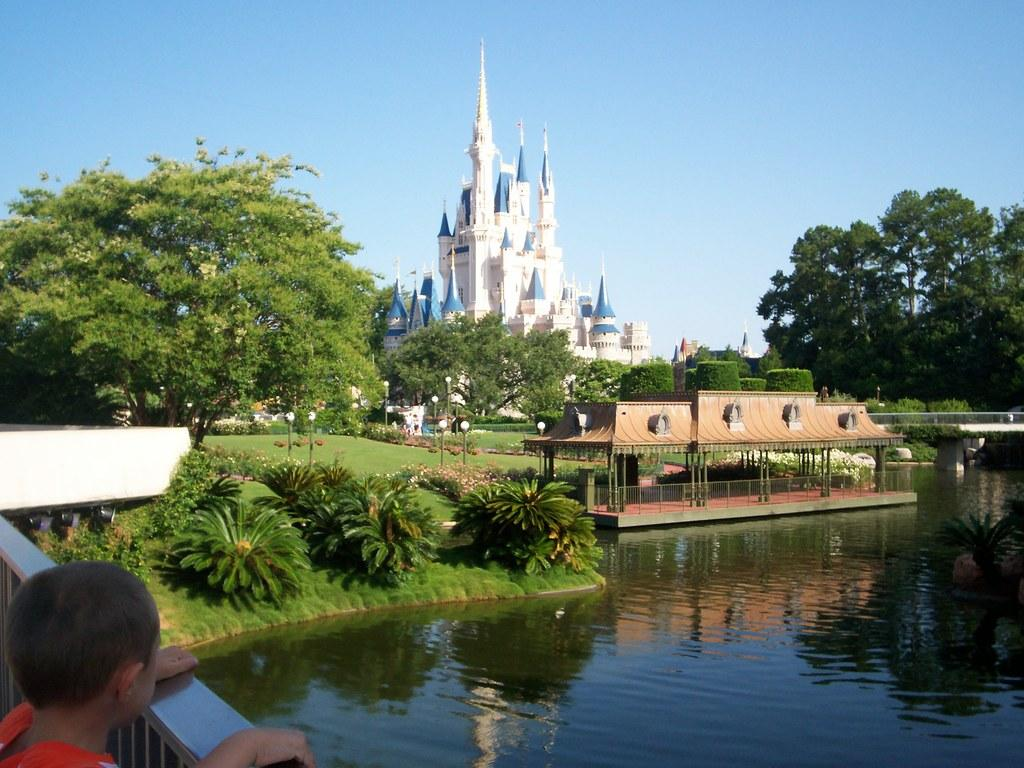What is the main subject of the image? There is a kid in the image. What can be seen in the background of the image? There are trees, buildings, lights on poles, and the sky visible in the background of the image. What type of natural environment is present in the image? There are plants, water, and grass visible in the image. What type of structure can be seen in the image? There is a shed in the image. What type of rice is being cooked in the pot in the image? There is no pot or rice present in the image. What type of office can be seen in the background of the image? There is no office visible in the image; only trees, buildings, lights on poles, and the sky can be seen in the background. 